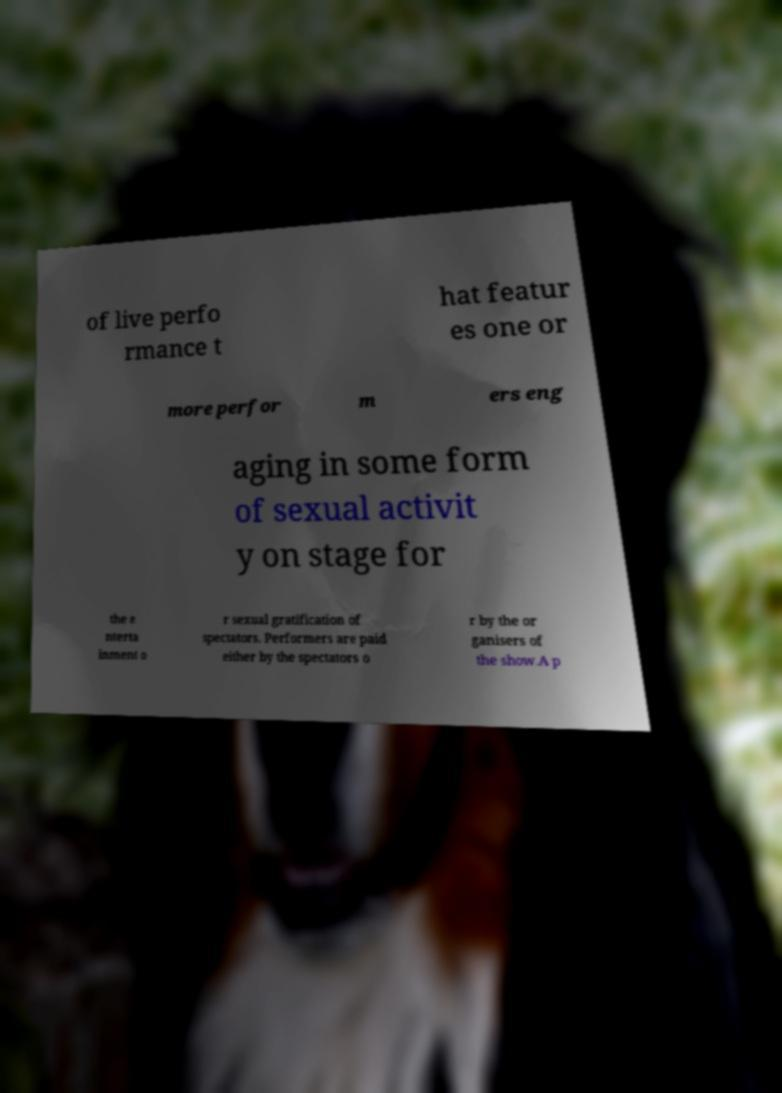Please read and relay the text visible in this image. What does it say? of live perfo rmance t hat featur es one or more perfor m ers eng aging in some form of sexual activit y on stage for the e nterta inment o r sexual gratification of spectators. Performers are paid either by the spectators o r by the or ganisers of the show.A p 